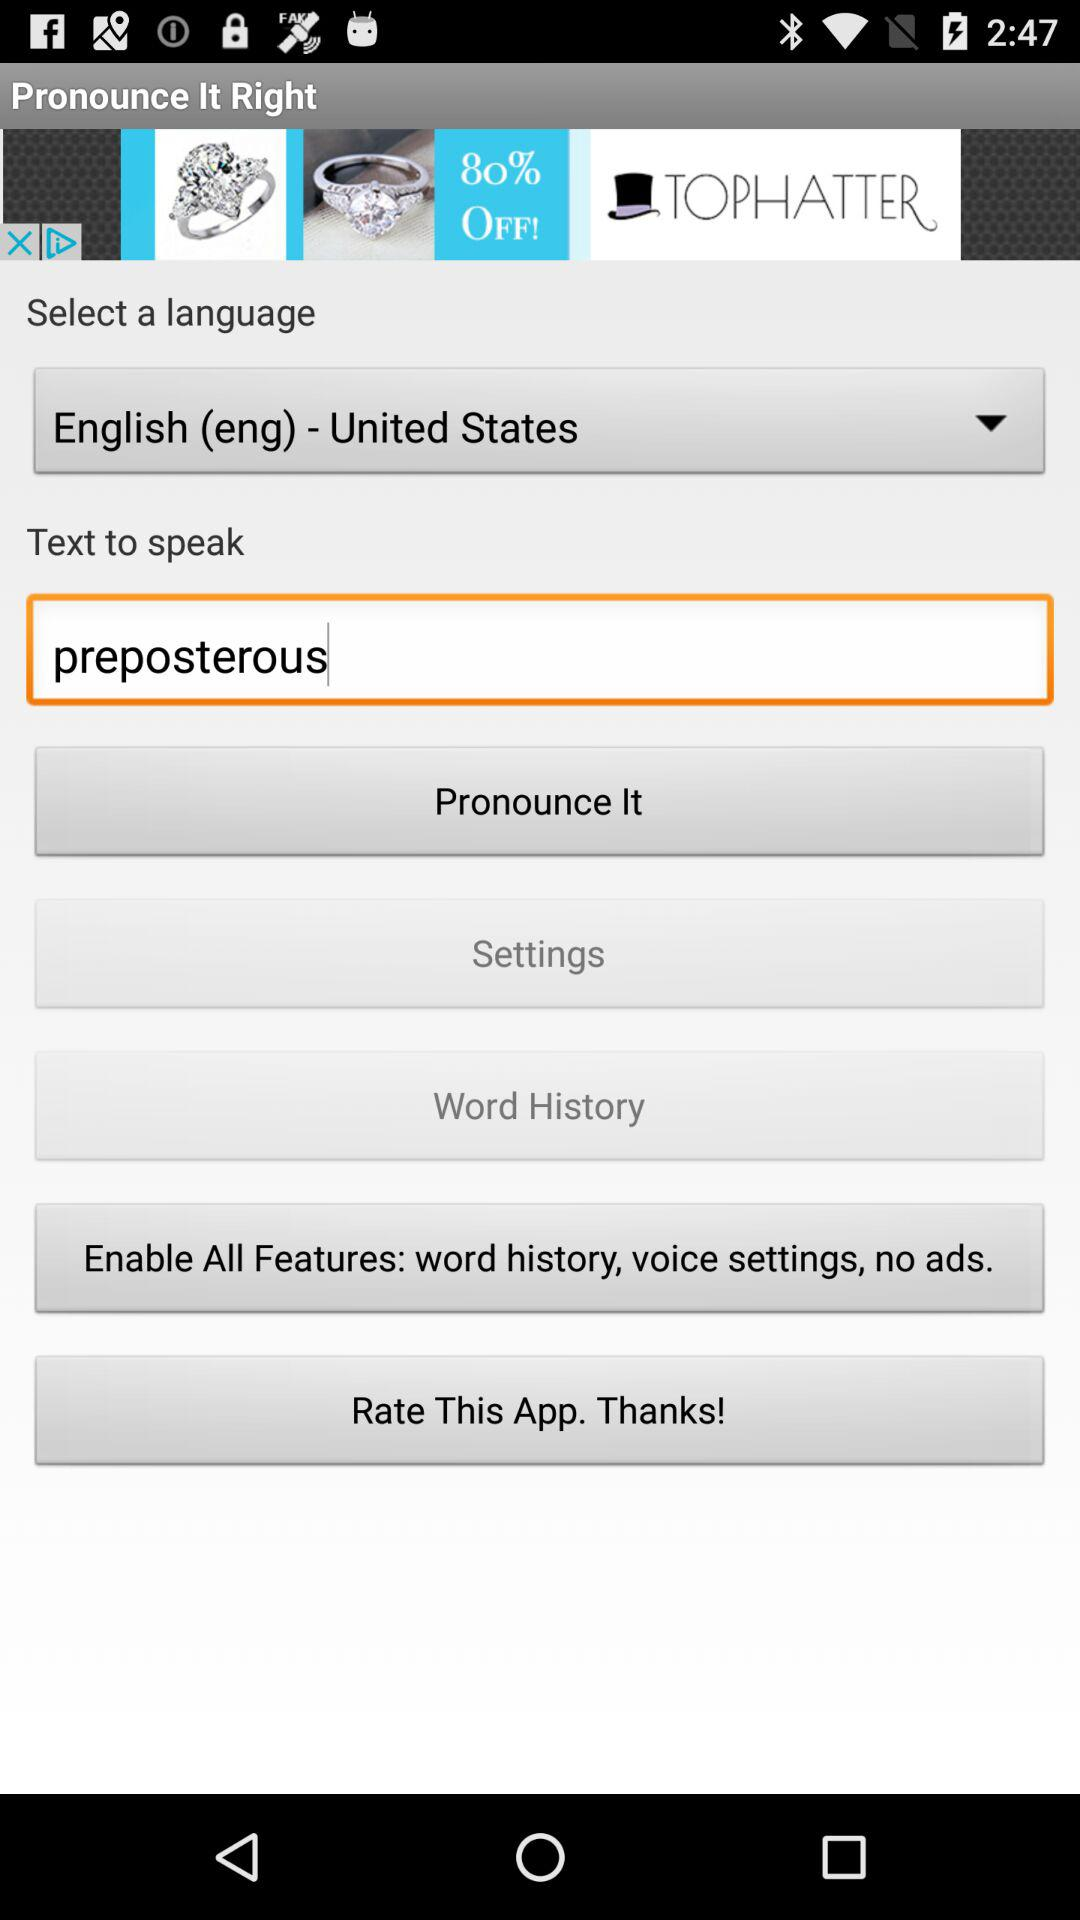What is the selected language? The selected language is "English (eng) - United States". 